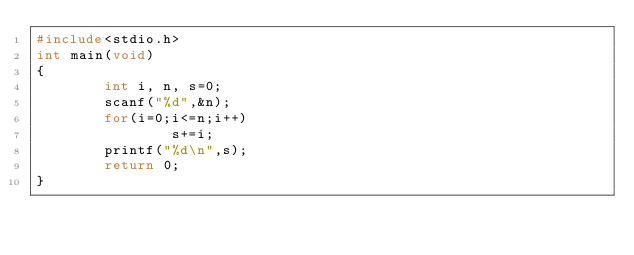<code> <loc_0><loc_0><loc_500><loc_500><_C_>#include<stdio.h>
int main(void)
{
        int i, n, s=0;
        scanf("%d",&n);
        for(i=0;i<=n;i++)
                s+=i;
        printf("%d\n",s);
        return 0;
}</code> 